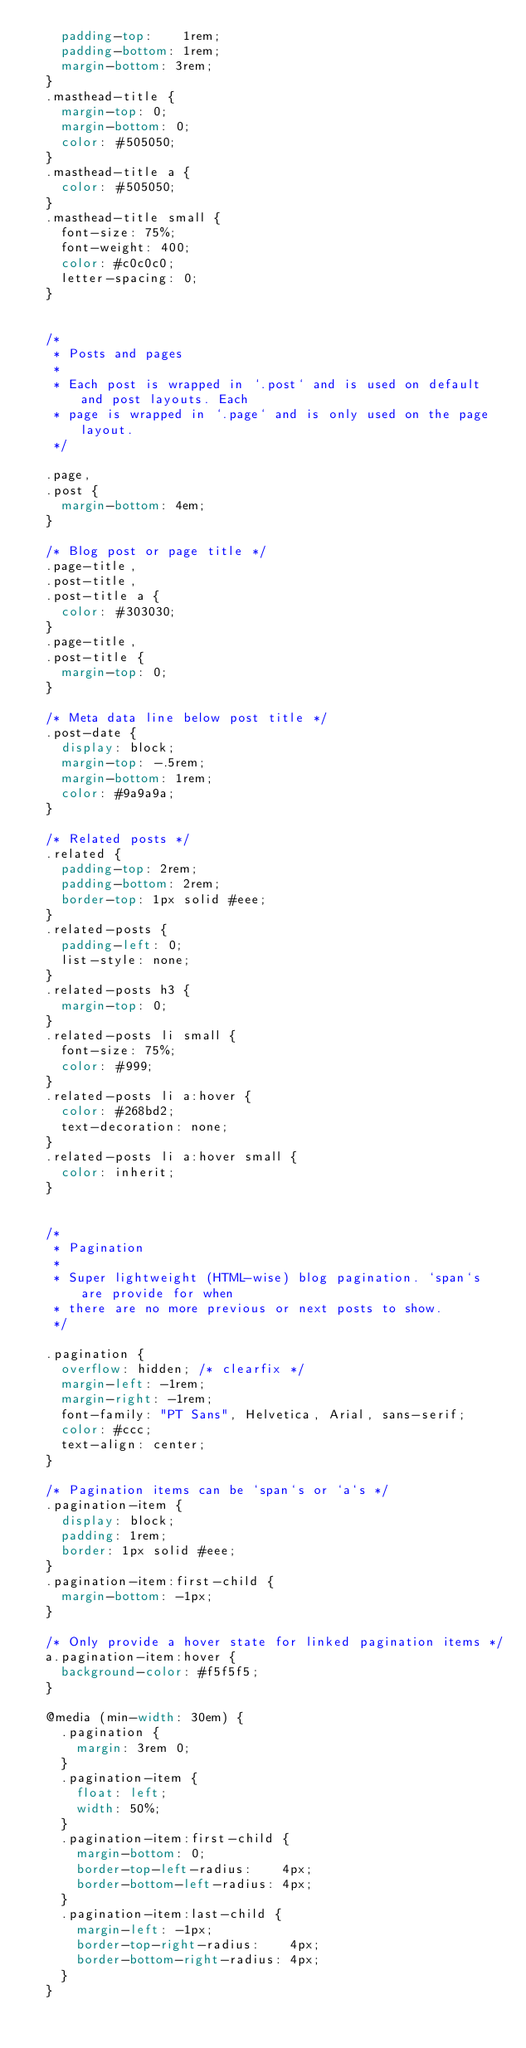Convert code to text. <code><loc_0><loc_0><loc_500><loc_500><_CSS_>    padding-top:    1rem;
    padding-bottom: 1rem;
    margin-bottom: 3rem;
  }
  .masthead-title {
    margin-top: 0;
    margin-bottom: 0;
    color: #505050;
  }
  .masthead-title a {
    color: #505050;
  }
  .masthead-title small {
    font-size: 75%;
    font-weight: 400;
    color: #c0c0c0;
    letter-spacing: 0;
  }
  
  
  /*
   * Posts and pages
   *
   * Each post is wrapped in `.post` and is used on default and post layouts. Each
   * page is wrapped in `.page` and is only used on the page layout.
   */
  
  .page,
  .post {
    margin-bottom: 4em;
  }
  
  /* Blog post or page title */
  .page-title,
  .post-title,
  .post-title a {
    color: #303030;
  }
  .page-title,
  .post-title {
    margin-top: 0;
  }
  
  /* Meta data line below post title */
  .post-date {
    display: block;
    margin-top: -.5rem;
    margin-bottom: 1rem;
    color: #9a9a9a;
  }
  
  /* Related posts */
  .related {
    padding-top: 2rem;
    padding-bottom: 2rem;
    border-top: 1px solid #eee;
  }
  .related-posts {
    padding-left: 0;
    list-style: none;
  }
  .related-posts h3 {
    margin-top: 0;
  }
  .related-posts li small {
    font-size: 75%;
    color: #999;
  }
  .related-posts li a:hover {
    color: #268bd2;
    text-decoration: none;
  }
  .related-posts li a:hover small {
    color: inherit;
  }
  
  
  /*
   * Pagination
   *
   * Super lightweight (HTML-wise) blog pagination. `span`s are provide for when
   * there are no more previous or next posts to show.
   */
  
  .pagination {
    overflow: hidden; /* clearfix */
    margin-left: -1rem;
    margin-right: -1rem;
    font-family: "PT Sans", Helvetica, Arial, sans-serif;
    color: #ccc;
    text-align: center;
  }
  
  /* Pagination items can be `span`s or `a`s */
  .pagination-item {
    display: block;
    padding: 1rem;
    border: 1px solid #eee;
  }
  .pagination-item:first-child {
    margin-bottom: -1px;
  }
  
  /* Only provide a hover state for linked pagination items */
  a.pagination-item:hover {
    background-color: #f5f5f5;
  }
  
  @media (min-width: 30em) {
    .pagination {
      margin: 3rem 0;
    }
    .pagination-item {
      float: left;
      width: 50%;
    }
    .pagination-item:first-child {
      margin-bottom: 0;
      border-top-left-radius:    4px;
      border-bottom-left-radius: 4px;
    }
    .pagination-item:last-child {
      margin-left: -1px;
      border-top-right-radius:    4px;
      border-bottom-right-radius: 4px;
    }
  }
  </code> 